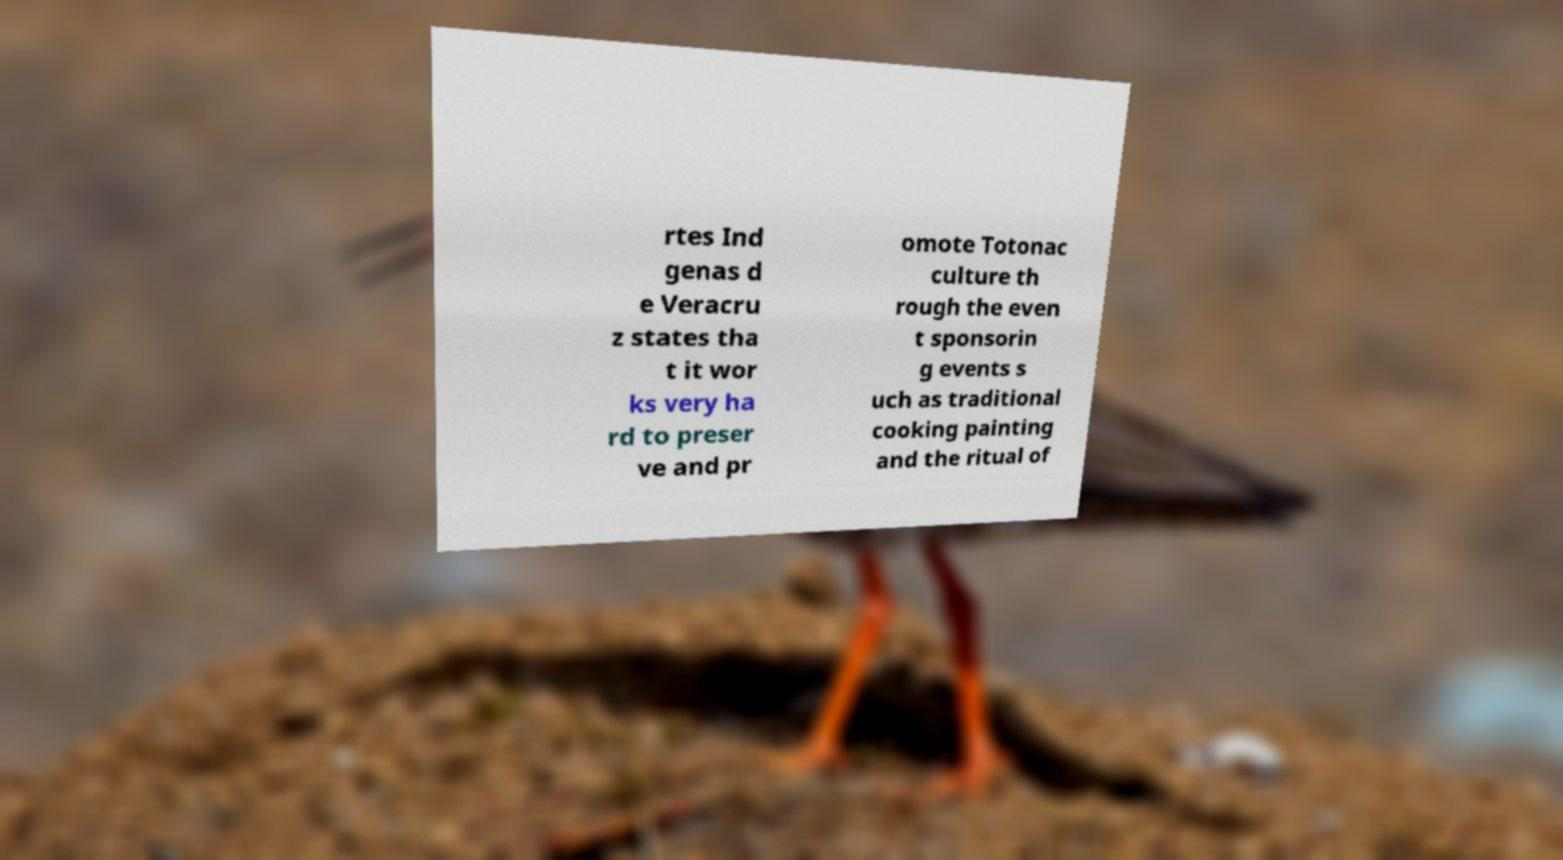Please read and relay the text visible in this image. What does it say? rtes Ind genas d e Veracru z states tha t it wor ks very ha rd to preser ve and pr omote Totonac culture th rough the even t sponsorin g events s uch as traditional cooking painting and the ritual of 